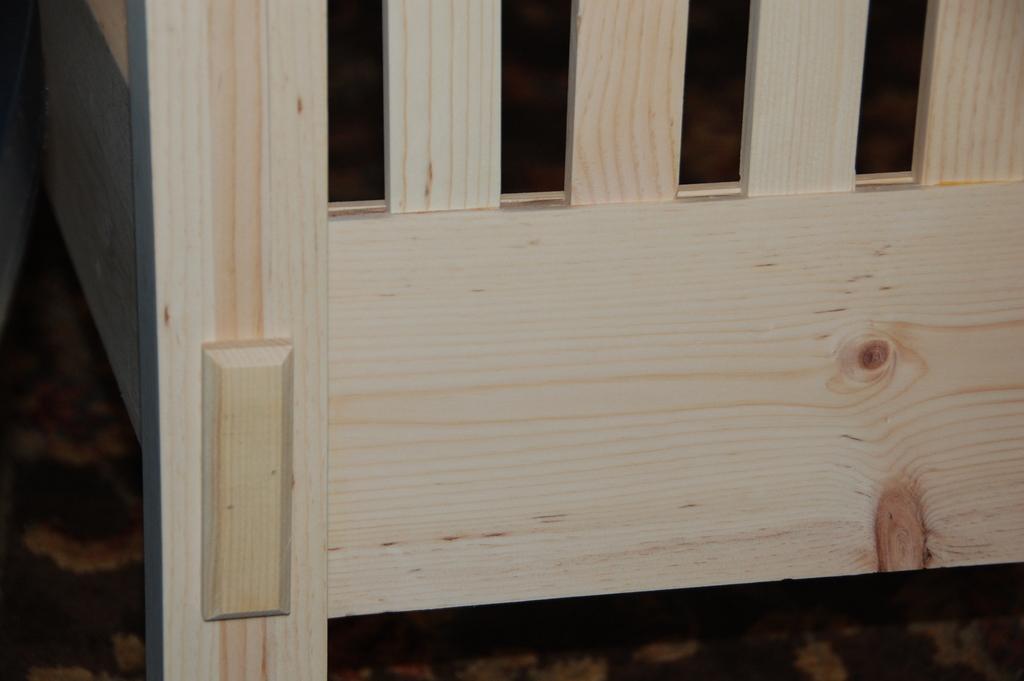Could you give a brief overview of what you see in this image? In this picture there is a wooden cot. 